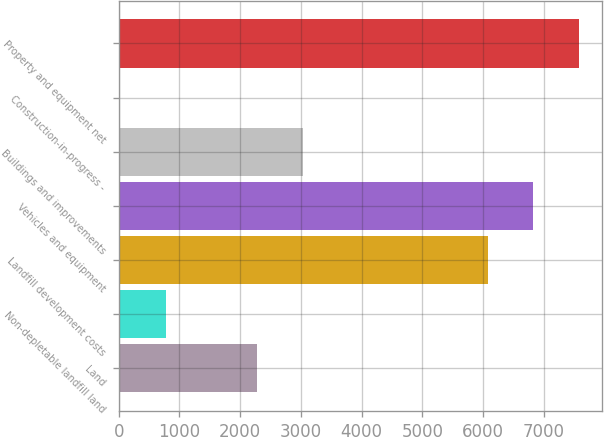Convert chart to OTSL. <chart><loc_0><loc_0><loc_500><loc_500><bar_chart><fcel>Land<fcel>Non-depletable landfill land<fcel>Landfill development costs<fcel>Vehicles and equipment<fcel>Buildings and improvements<fcel>Construction-in-progress -<fcel>Property and equipment net<nl><fcel>2283.69<fcel>778.23<fcel>6078.1<fcel>6830.83<fcel>3036.42<fcel>25.5<fcel>7583.56<nl></chart> 